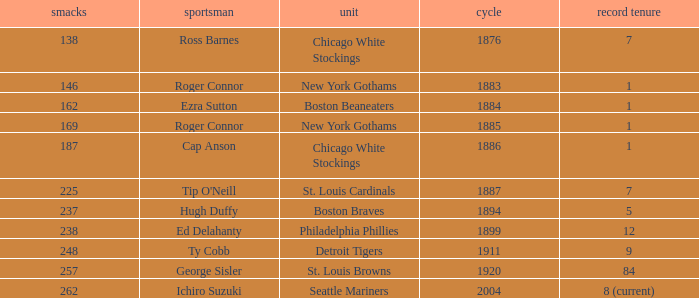Name the hits for years before 1883 138.0. Help me parse the entirety of this table. {'header': ['smacks', 'sportsman', 'unit', 'cycle', 'record tenure'], 'rows': [['138', 'Ross Barnes', 'Chicago White Stockings', '1876', '7'], ['146', 'Roger Connor', 'New York Gothams', '1883', '1'], ['162', 'Ezra Sutton', 'Boston Beaneaters', '1884', '1'], ['169', 'Roger Connor', 'New York Gothams', '1885', '1'], ['187', 'Cap Anson', 'Chicago White Stockings', '1886', '1'], ['225', "Tip O'Neill", 'St. Louis Cardinals', '1887', '7'], ['237', 'Hugh Duffy', 'Boston Braves', '1894', '5'], ['238', 'Ed Delahanty', 'Philadelphia Phillies', '1899', '12'], ['248', 'Ty Cobb', 'Detroit Tigers', '1911', '9'], ['257', 'George Sisler', 'St. Louis Browns', '1920', '84'], ['262', 'Ichiro Suzuki', 'Seattle Mariners', '2004', '8 (current)']]} 